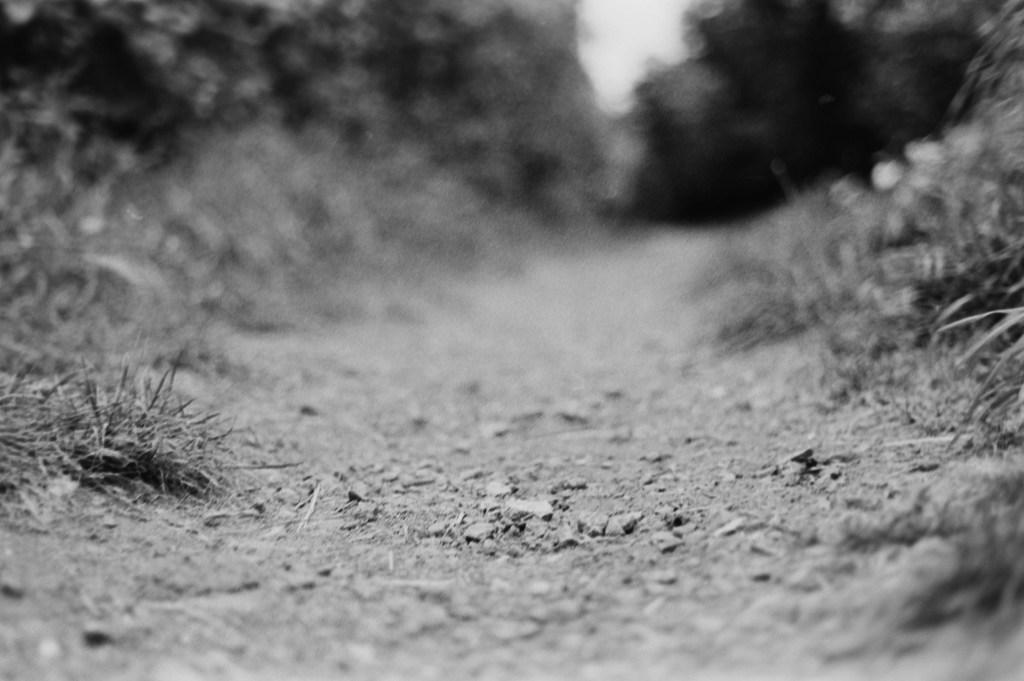What type of road is shown in the image? The image depicts a mud road. What can be seen on the left side of the image? There are trees on the left side of the image. What can be seen on the right side of the image? There are trees on the right side of the image. What is visible at the top of the image? The sky is visible at the top of the image. What is present at the bottom of the image? Small stones and grass are present at the bottom of the image. What type of vegetable is growing on the wrist of the person in the image? There is no person present in the image, and therefore no wrist or vegetable can be observed. 